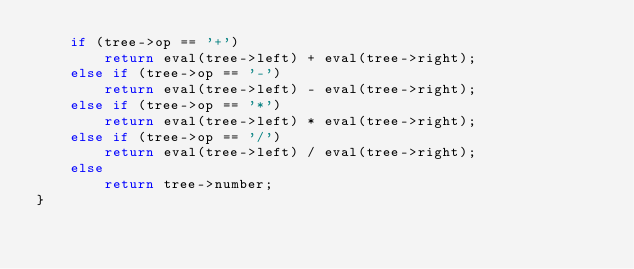<code> <loc_0><loc_0><loc_500><loc_500><_C++_>    if (tree->op == '+')
        return eval(tree->left) + eval(tree->right);
    else if (tree->op == '-')
        return eval(tree->left) - eval(tree->right);
    else if (tree->op == '*')
        return eval(tree->left) * eval(tree->right);
    else if (tree->op == '/')
        return eval(tree->left) / eval(tree->right);
    else
        return tree->number;
}
</code> 